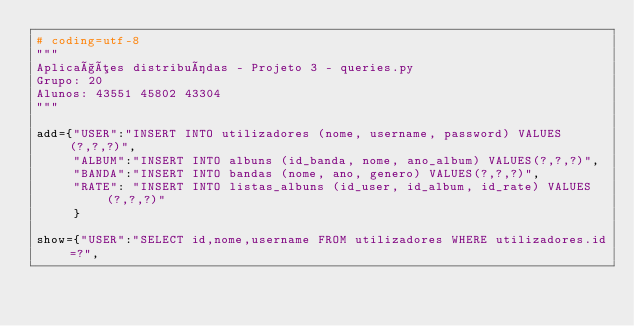<code> <loc_0><loc_0><loc_500><loc_500><_Python_># coding=utf-8
"""
Aplicações distribuídas - Projeto 3 - queries.py
Grupo: 20
Alunos: 43551 45802 43304
"""

add={"USER":"INSERT INTO utilizadores (nome, username, password) VALUES (?,?,?)",
     "ALBUM":"INSERT INTO albuns (id_banda, nome, ano_album) VALUES(?,?,?)",
     "BANDA":"INSERT INTO bandas (nome, ano, genero) VALUES(?,?,?)",
     "RATE": "INSERT INTO listas_albuns (id_user, id_album, id_rate) VALUES(?,?,?)"
     }

show={"USER":"SELECT id,nome,username FROM utilizadores WHERE utilizadores.id=?",</code> 